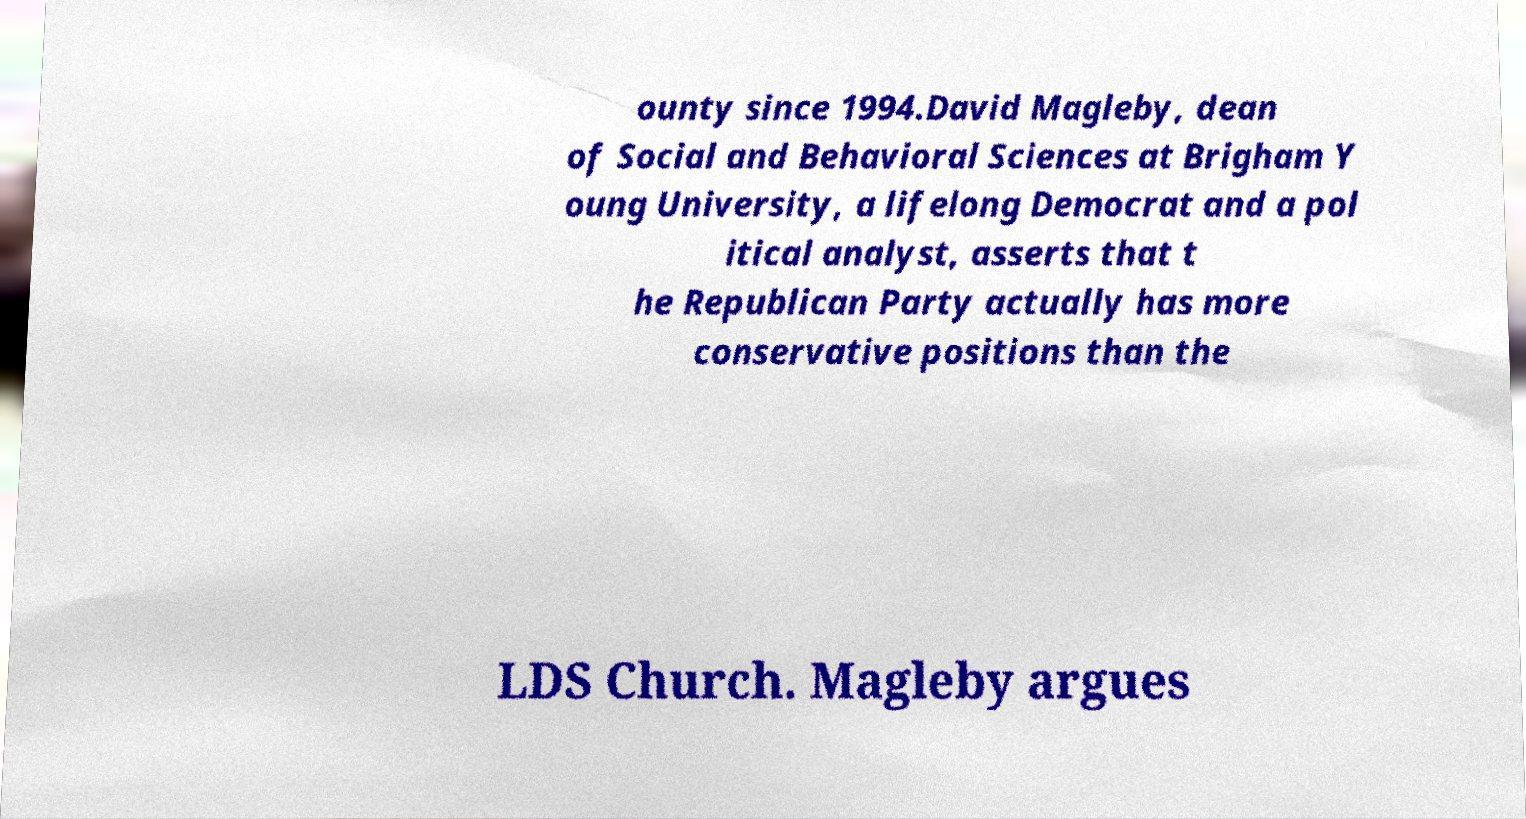Please identify and transcribe the text found in this image. ounty since 1994.David Magleby, dean of Social and Behavioral Sciences at Brigham Y oung University, a lifelong Democrat and a pol itical analyst, asserts that t he Republican Party actually has more conservative positions than the LDS Church. Magleby argues 